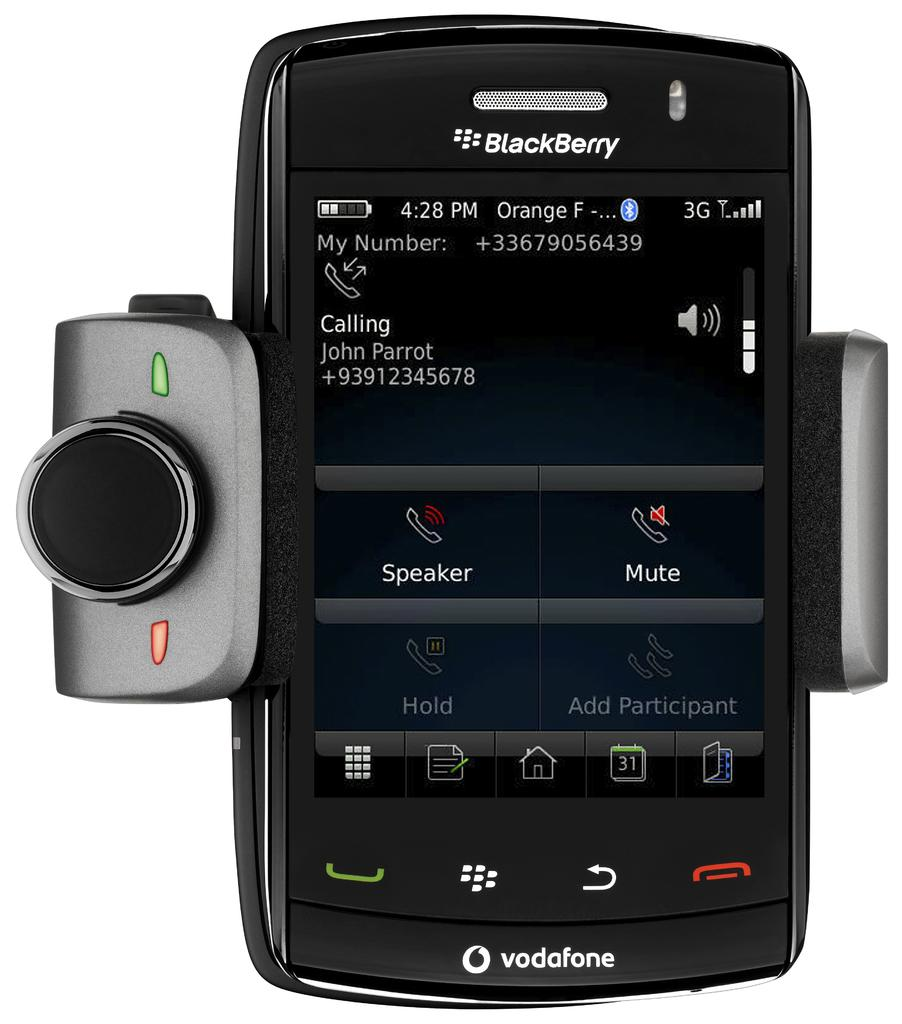<image>
Provide a brief description of the given image. A Blackberry is showing a call from John Parrot. 